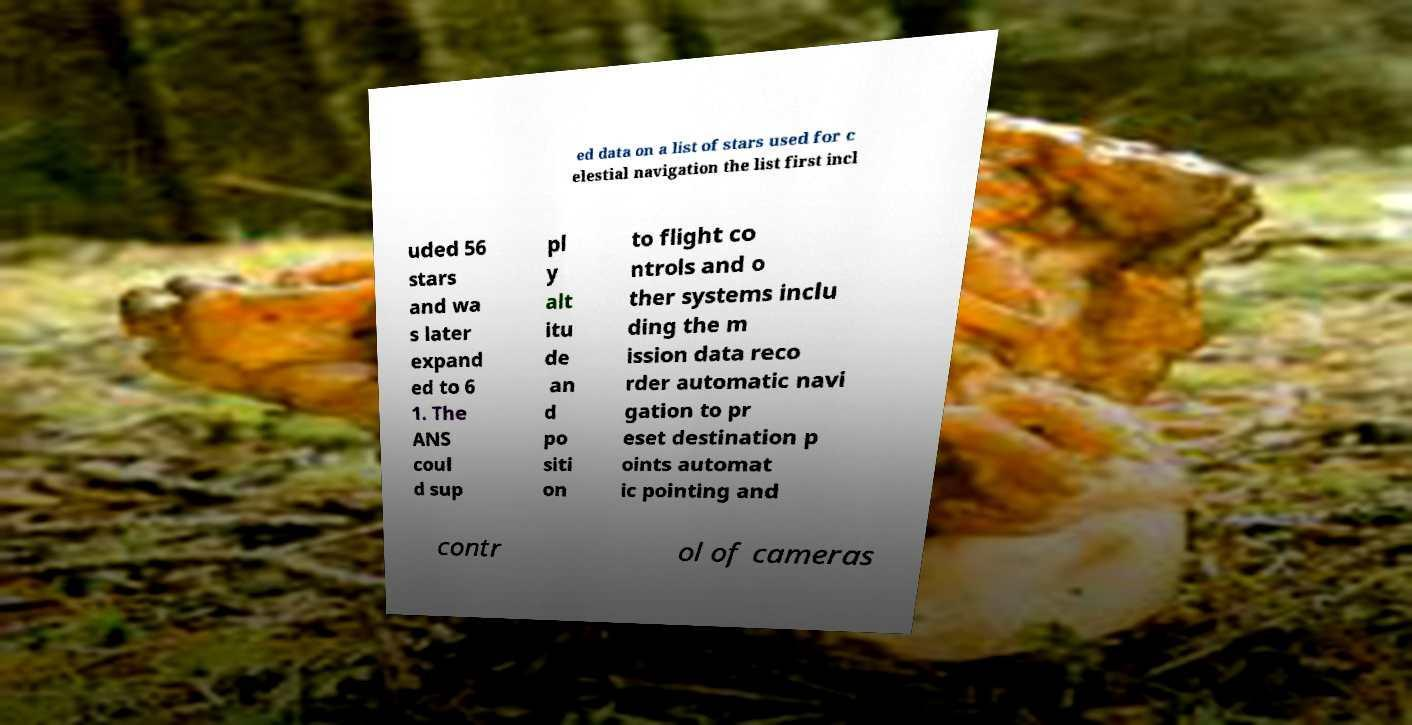I need the written content from this picture converted into text. Can you do that? ed data on a list of stars used for c elestial navigation the list first incl uded 56 stars and wa s later expand ed to 6 1. The ANS coul d sup pl y alt itu de an d po siti on to flight co ntrols and o ther systems inclu ding the m ission data reco rder automatic navi gation to pr eset destination p oints automat ic pointing and contr ol of cameras 